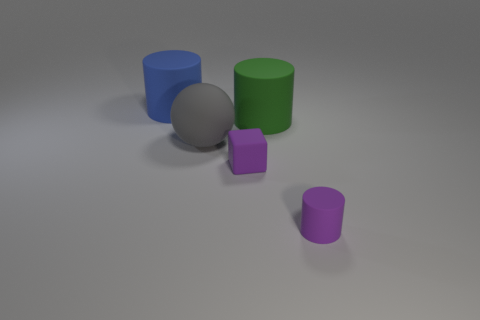Add 1 tiny brown shiny balls. How many objects exist? 6 Subtract all blocks. How many objects are left? 4 Add 5 gray spheres. How many gray spheres exist? 6 Subtract 0 brown spheres. How many objects are left? 5 Subtract all tiny blue shiny balls. Subtract all small purple rubber things. How many objects are left? 3 Add 1 large green objects. How many large green objects are left? 2 